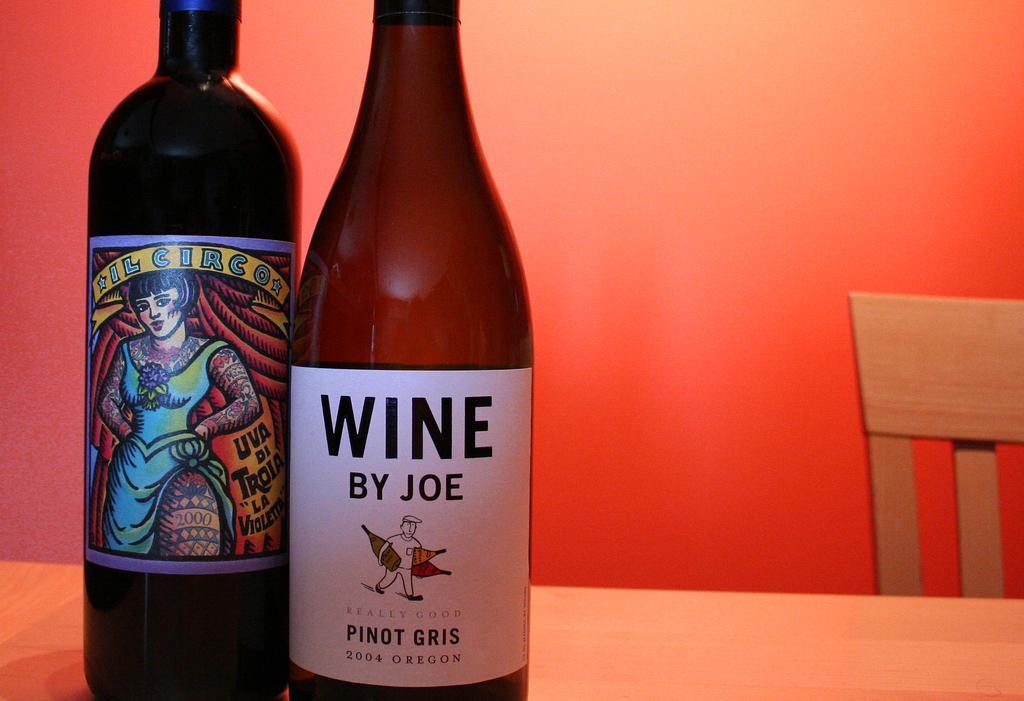<image>
Describe the image concisely. A bottle of wine by Joe sits next to another more colorful bottle. 